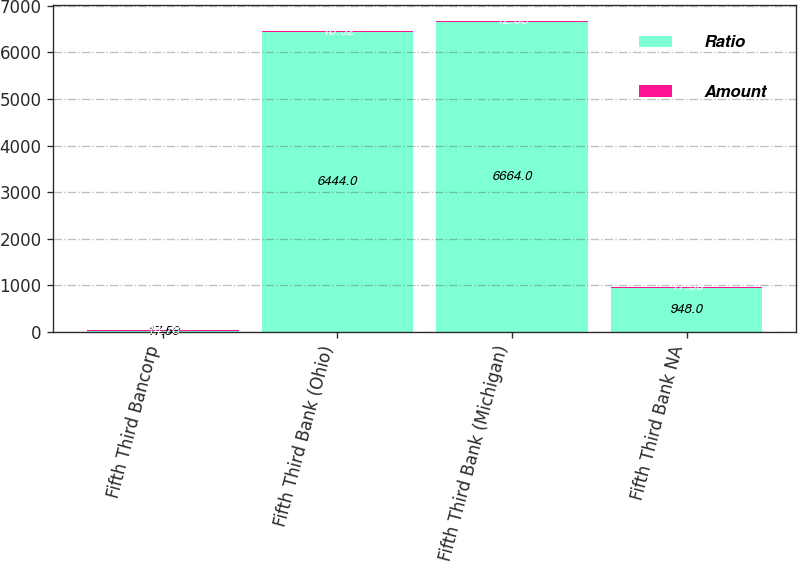<chart> <loc_0><loc_0><loc_500><loc_500><stacked_bar_chart><ecel><fcel>Fifth Third Bancorp<fcel>Fifth Third Bank (Ohio)<fcel>Fifth Third Bank (Michigan)<fcel>Fifth Third Bank NA<nl><fcel>Ratio<fcel>17.59<fcel>6444<fcel>6664<fcel>948<nl><fcel>Amount<fcel>14.78<fcel>10.92<fcel>12.95<fcel>17.59<nl></chart> 